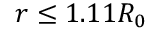Convert formula to latex. <formula><loc_0><loc_0><loc_500><loc_500>r \leq 1 . 1 1 R _ { 0 }</formula> 